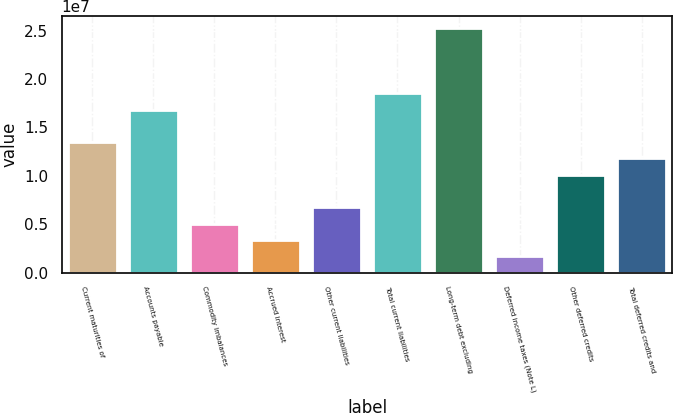<chart> <loc_0><loc_0><loc_500><loc_500><bar_chart><fcel>Current maturities of<fcel>Accounts payable<fcel>Commodity imbalances<fcel>Accrued interest<fcel>Other current liabilities<fcel>Total current liabilities<fcel>Long-term debt excluding<fcel>Deferred income taxes (Note L)<fcel>Other deferred credits<fcel>Total deferred credits and<nl><fcel>1.34776e+07<fcel>1.68459e+07<fcel>5.05674e+06<fcel>3.37257e+06<fcel>6.74091e+06<fcel>1.85301e+07<fcel>2.52668e+07<fcel>1.6884e+06<fcel>1.01093e+07<fcel>1.17934e+07<nl></chart> 